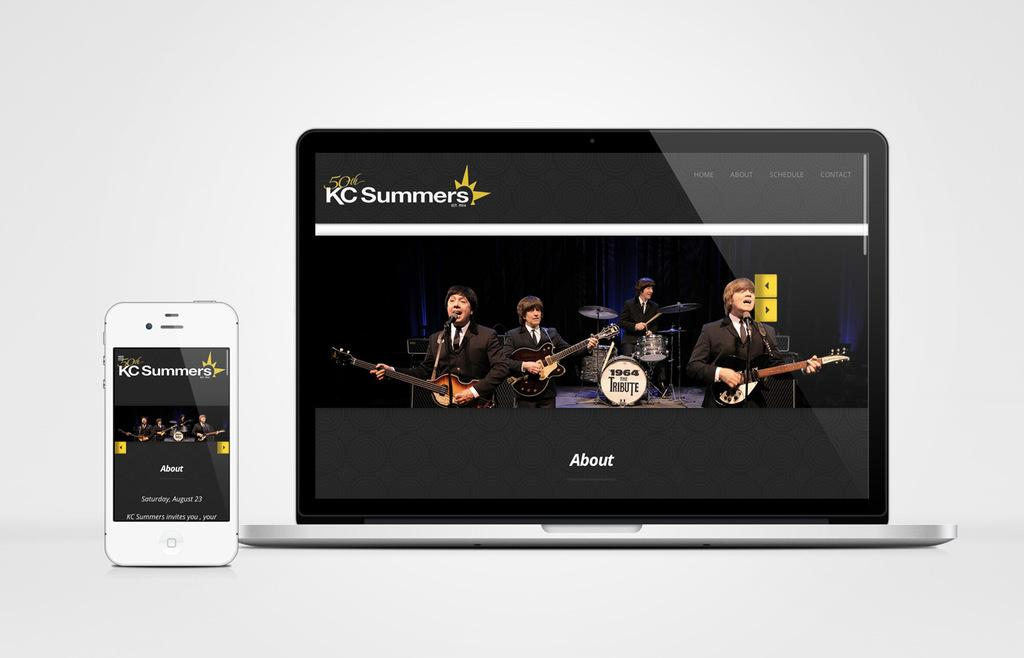<image>
Give a short and clear explanation of the subsequent image. a screen with people on it with the word about 